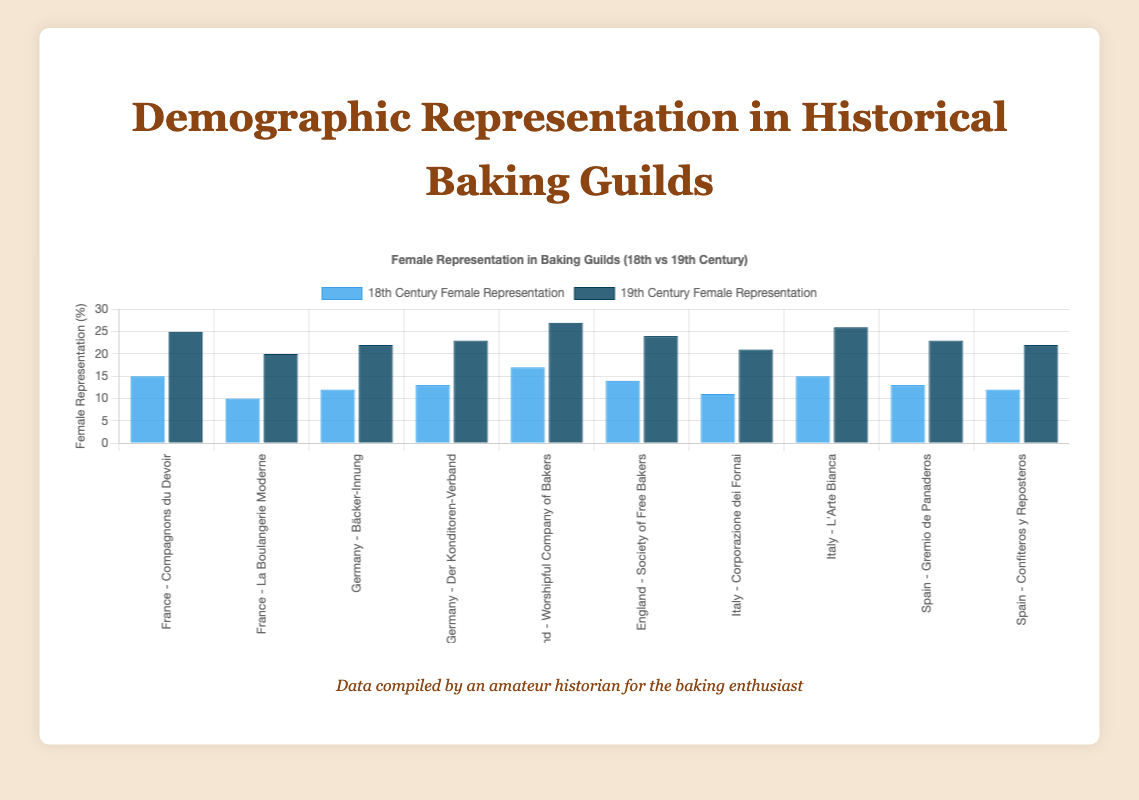Which guild in France had a higher female representation in the 19th century? Look at the heights of the bars for France in the 19th century. Compare the two bars corresponding to "Compagnons du Devoir" and "La Boulangerie Moderne." The bar for "Compagnons du Devoir" is higher.
Answer: Compagnons du Devoir How much did the female representation in the "Worshipful Company of Bakers" guild in England change from the 18th to the 19th century? Identify the heights of the bars for "Worshipful Company of Bakers" in the 18th and 19th centuries. Subtract the 18th century value (17%) from the 19th century value (27%).
Answer: 10% Which region had the highest female representation in the 18th century? Compare the heights of the 18th century bars for each guild across all regions. The highest bar is for "La Boulangerie Moderne" in France.
Answer: France What is the average female representation in the 19th century for the guilds in Germany? Identify the heights of the bars for "Bäcker-Innung" and "Der Konditoren-Verband" in the 19th century. Add the values (22% + 23%) and divide by 2.
Answer: 22.5% Was female representation higher in Italy for the 18th or 19th century? Compare the heights of the bars for Italian guilds. The 19th century bars for "Corporazione dei Fornai" and "L'Arte Bianca" are higher than the 18th century bars.
Answer: 19th century What is the difference in female representation between "Gremio de Panaderos" and "Confiteros y Reposteros" in Spain in the 19th century? Identify the heights of the bars for "Gremio de Panaderos" and "Confiteros y Reposteros" in the 19th century. Subtract the smaller value (22%) from the larger value (23%).
Answer: 1% Did any guild in the presented regions have equal female representation in both centuries? Closely examine the heights of the bars for each guild in both centuries. None of the bars are equal for both centuries across any guilds.
Answer: No Which guild shows the greatest increase in female representation from the 18th to the 19th century? Calculate the difference from the 18th to the 19th century for each guild. "Worshipful Company of Bakers" shows the greatest increase, from 17% to 27%, an increase of 10%.
Answer: Worshipful Company of Bakers In which century was the "Bäcker-Innung" guild's female representation closer to the average of its region (Germany)? Calculate the average female representation for Germany in both centuries. In the 18th century, the average is (12% + 13%)/2 = 12.5%. For the 19th century, it is (22% + 23%)/2 = 22.5%. Compare the "Bäcker-Innung" values (12% and 22%). In the 19th century, it is closer to the regional average.
Answer: 19th century 